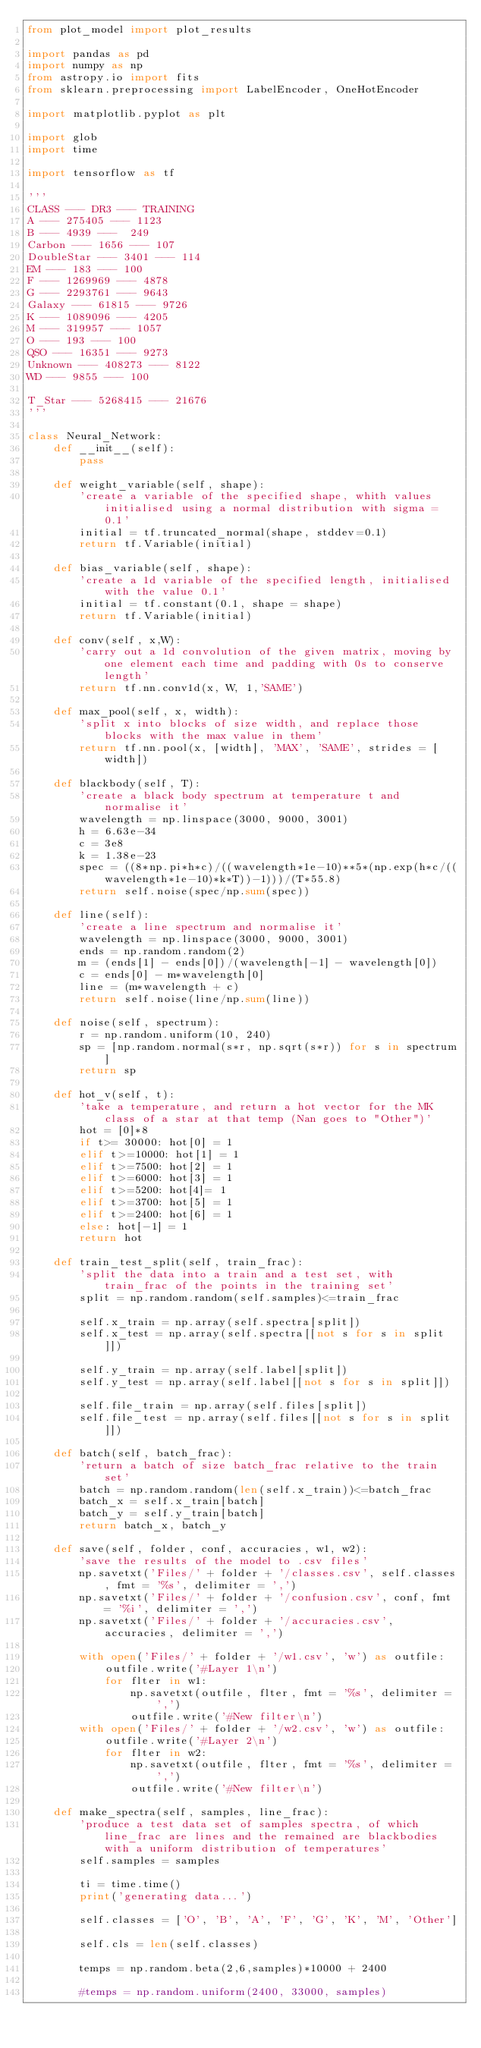<code> <loc_0><loc_0><loc_500><loc_500><_Python_>from plot_model import plot_results

import pandas as pd
import numpy as np
from astropy.io import fits
from sklearn.preprocessing import LabelEncoder, OneHotEncoder

import matplotlib.pyplot as plt

import glob
import time

import tensorflow as tf

'''
CLASS --- DR3 --- TRAINING
A --- 275405 --- 1123
B --- 4939 ---  249
Carbon --- 1656 --- 107
DoubleStar --- 3401 --- 114
EM --- 183 --- 100
F --- 1269969 --- 4878
G --- 2293761 --- 9643
Galaxy --- 61815 --- 9726
K --- 1089096 --- 4205
M --- 319957 --- 1057
O --- 193 --- 100
QSO --- 16351 --- 9273
Unknown --- 408273 --- 8122
WD --- 9855 --- 100

T_Star --- 5268415 --- 21676
'''

class Neural_Network:
    def __init__(self):
        pass
    
    def weight_variable(self, shape):
        'create a variable of the specified shape, whith values initialised using a normal distribution with sigma = 0.1'
        initial = tf.truncated_normal(shape, stddev=0.1)
        return tf.Variable(initial)
        
    def bias_variable(self, shape):
        'create a 1d variable of the specified length, initialised with the value 0.1'
        initial = tf.constant(0.1, shape = shape)
        return tf.Variable(initial)
        
    def conv(self, x,W):
        'carry out a 1d convolution of the given matrix, moving by one element each time and padding with 0s to conserve length'
        return tf.nn.conv1d(x, W, 1,'SAME')
        
    def max_pool(self, x, width):
        'split x into blocks of size width, and replace those blocks with the max value in them'
        return tf.nn.pool(x, [width], 'MAX', 'SAME', strides = [width])
    
    def blackbody(self, T):
        'create a black body spectrum at temperature t and normalise it'
        wavelength = np.linspace(3000, 9000, 3001)
        h = 6.63e-34
        c = 3e8
        k = 1.38e-23
        spec = ((8*np.pi*h*c)/((wavelength*1e-10)**5*(np.exp(h*c/((wavelength*1e-10)*k*T))-1)))/(T*55.8)
        return self.noise(spec/np.sum(spec))
    
    def line(self):
        'create a line spectrum and normalise it'
        wavelength = np.linspace(3000, 9000, 3001)
        ends = np.random.random(2)
        m = (ends[1] - ends[0])/(wavelength[-1] - wavelength[0])
        c = ends[0] - m*wavelength[0]
        line = (m*wavelength + c)
        return self.noise(line/np.sum(line))
    
    def noise(self, spectrum):
        r = np.random.uniform(10, 240)
        sp = [np.random.normal(s*r, np.sqrt(s*r)) for s in spectrum]
        return sp

    def hot_v(self, t):
        'take a temperature, and return a hot vector for the MK class of a star at that temp (Nan goes to "Other")'
        hot = [0]*8
        if t>= 30000: hot[0] = 1
        elif t>=10000: hot[1] = 1
        elif t>=7500: hot[2] = 1
        elif t>=6000: hot[3] = 1
        elif t>=5200: hot[4]= 1
        elif t>=3700: hot[5] = 1
        elif t>=2400: hot[6] = 1
        else: hot[-1] = 1
        return hot

    def train_test_split(self, train_frac):
        'split the data into a train and a test set, with train_frac of the points in the training set'
        split = np.random.random(self.samples)<=train_frac

        self.x_train = np.array(self.spectra[split])
        self.x_test = np.array(self.spectra[[not s for s in split]])
        
        self.y_train = np.array(self.label[split])
        self.y_test = np.array(self.label[[not s for s in split]])
        
        self.file_train = np.array(self.files[split])
        self.file_test = np.array(self.files[[not s for s in split]])
        
    def batch(self, batch_frac):
        'return a batch of size batch_frac relative to the train set'
        batch = np.random.random(len(self.x_train))<=batch_frac
        batch_x = self.x_train[batch]
        batch_y = self.y_train[batch]
        return batch_x, batch_y
    
    def save(self, folder, conf, accuracies, w1, w2):
        'save the results of the model to .csv files'
        np.savetxt('Files/' + folder + '/classes.csv', self.classes, fmt = '%s', delimiter = ',')
        np.savetxt('Files/' + folder + '/confusion.csv', conf, fmt = '%i', delimiter = ',')
        np.savetxt('Files/' + folder + '/accuracies.csv', accuracies, delimiter = ',')

        with open('Files/' + folder + '/w1.csv', 'w') as outfile:
            outfile.write('#Layer 1\n')
            for flter in w1:
                np.savetxt(outfile, flter, fmt = '%s', delimiter = ',')
                outfile.write('#New filter\n')
        with open('Files/' + folder + '/w2.csv', 'w') as outfile:
            outfile.write('#Layer 2\n')
            for flter in w2:
                np.savetxt(outfile, flter, fmt = '%s', delimiter = ',')
                outfile.write('#New filter\n')

    def make_spectra(self, samples, line_frac): 
        'produce a test data set of samples spectra, of which line_frac are lines and the remained are blackbodies with a uniform distribution of temperatures'
        self.samples = samples
        
        ti = time.time()
        print('generating data...')
        
        self.classes = ['O', 'B', 'A', 'F', 'G', 'K', 'M', 'Other']
        
        self.cls = len(self.classes)
        
        temps = np.random.beta(2,6,samples)*10000 + 2400
        
        #temps = np.random.uniform(2400, 33000, samples)
        </code> 